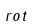<formula> <loc_0><loc_0><loc_500><loc_500>r o t</formula> 